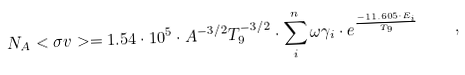<formula> <loc_0><loc_0><loc_500><loc_500>N _ { A } < \sigma v > = 1 . 5 4 \cdot 1 0 ^ { 5 } \cdot A ^ { - 3 / 2 } T _ { 9 } ^ { - 3 / 2 } \cdot \sum _ { i } ^ { n } \omega \gamma _ { i } \cdot e ^ { \frac { - 1 1 . 6 0 5 \cdot E _ { i } } { T _ { 9 } } } \quad ,</formula> 